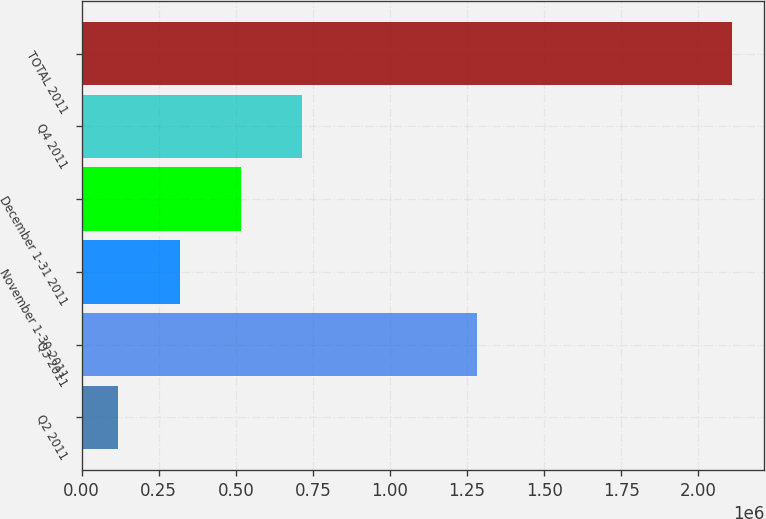Convert chart. <chart><loc_0><loc_0><loc_500><loc_500><bar_chart><fcel>Q2 2011<fcel>Q3 2011<fcel>November 1-30 2011<fcel>December 1-31 2011<fcel>Q4 2011<fcel>TOTAL 2011<nl><fcel>118578<fcel>1.28281e+06<fcel>317536<fcel>516494<fcel>715452<fcel>2.10816e+06<nl></chart> 